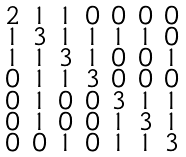<formula> <loc_0><loc_0><loc_500><loc_500>\begin{smallmatrix} 2 & 1 & 1 & 0 & 0 & 0 & 0 \\ 1 & 3 & 1 & 1 & 1 & 1 & 0 \\ 1 & 1 & 3 & 1 & 0 & 0 & 1 \\ 0 & 1 & 1 & 3 & 0 & 0 & 0 \\ 0 & 1 & 0 & 0 & 3 & 1 & 1 \\ 0 & 1 & 0 & 0 & 1 & 3 & 1 \\ 0 & 0 & 1 & 0 & 1 & 1 & 3 \end{smallmatrix}</formula> 